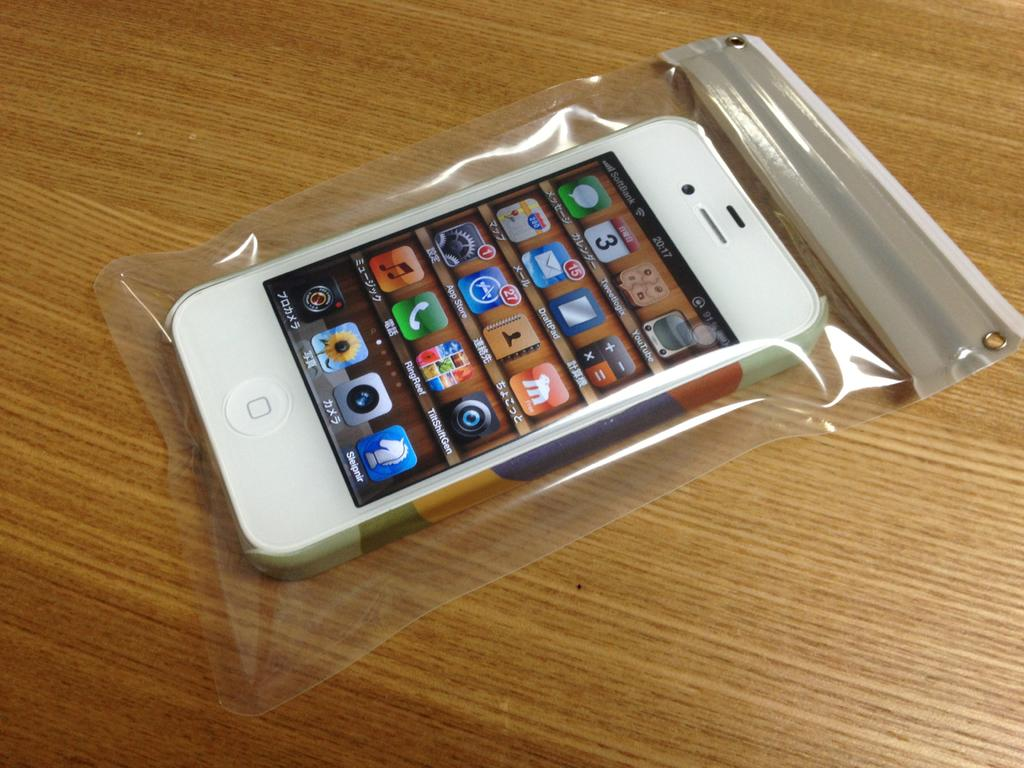<image>
Describe the image concisely. A phone in a bag has service from SoftBank. 